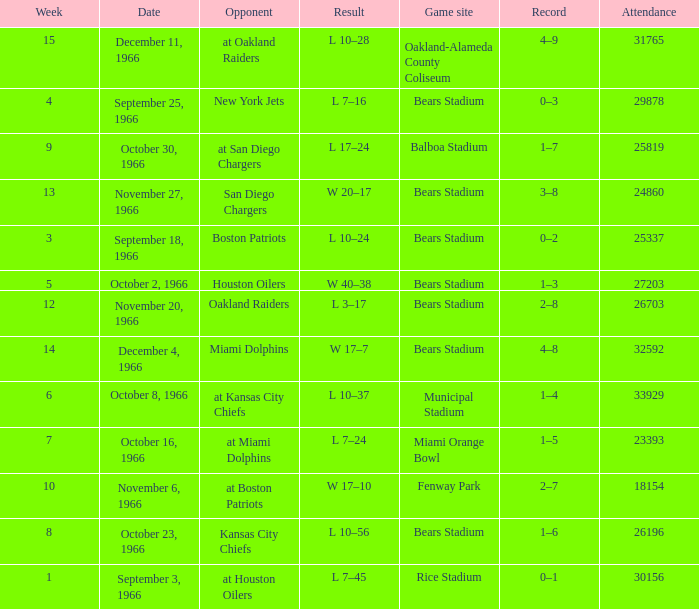On October 16, 1966, what was the game site? Miami Orange Bowl. 